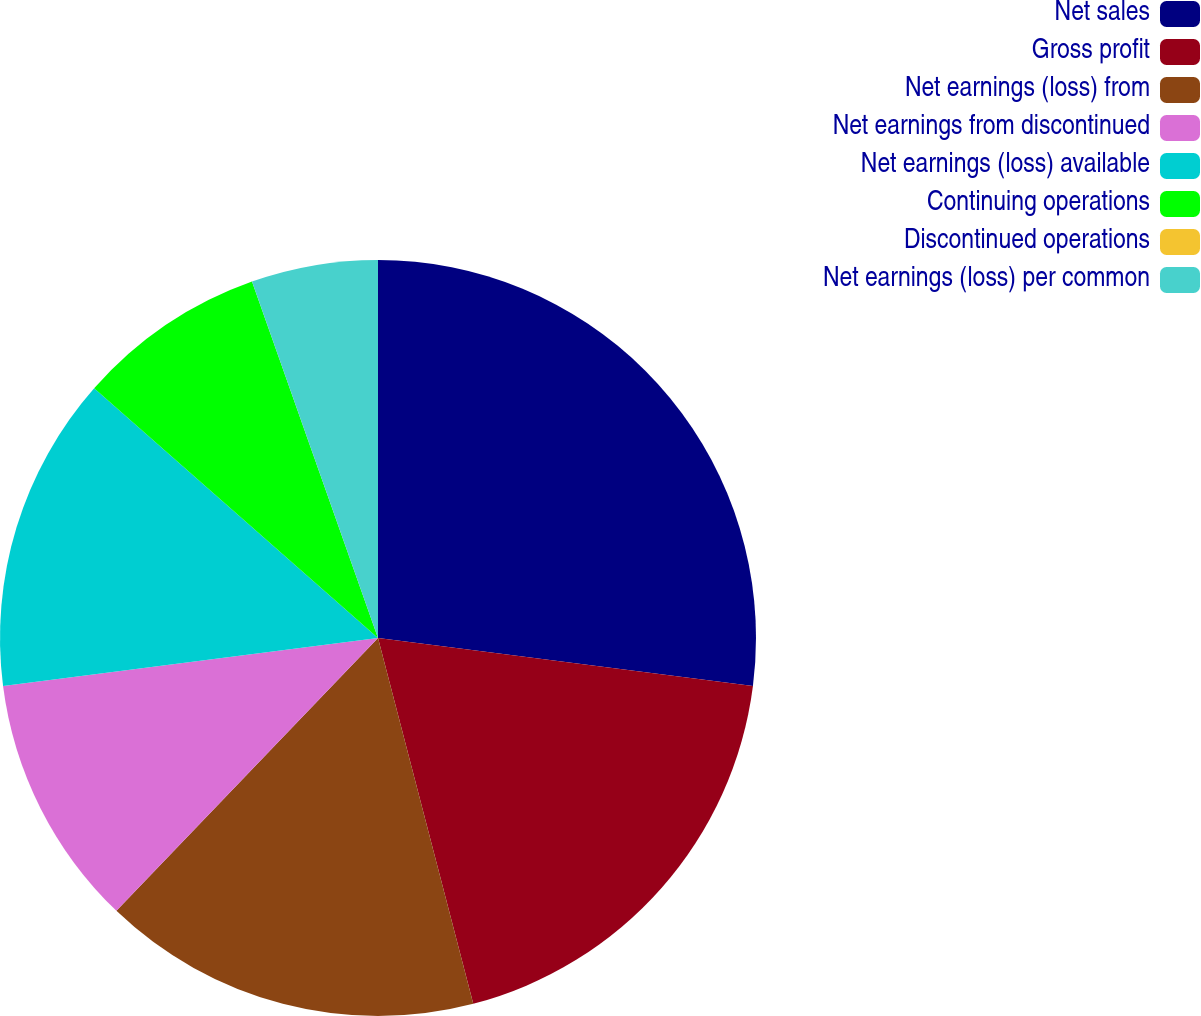Convert chart to OTSL. <chart><loc_0><loc_0><loc_500><loc_500><pie_chart><fcel>Net sales<fcel>Gross profit<fcel>Net earnings (loss) from<fcel>Net earnings from discontinued<fcel>Net earnings (loss) available<fcel>Continuing operations<fcel>Discontinued operations<fcel>Net earnings (loss) per common<nl><fcel>27.03%<fcel>18.92%<fcel>16.22%<fcel>10.81%<fcel>13.51%<fcel>8.11%<fcel>0.0%<fcel>5.41%<nl></chart> 